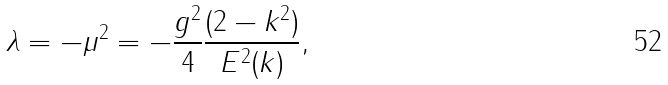Convert formula to latex. <formula><loc_0><loc_0><loc_500><loc_500>\lambda = - \mu ^ { 2 } = - \frac { g ^ { 2 } } { 4 } \frac { ( 2 - k ^ { 2 } ) } { E ^ { 2 } ( k ) } ,</formula> 